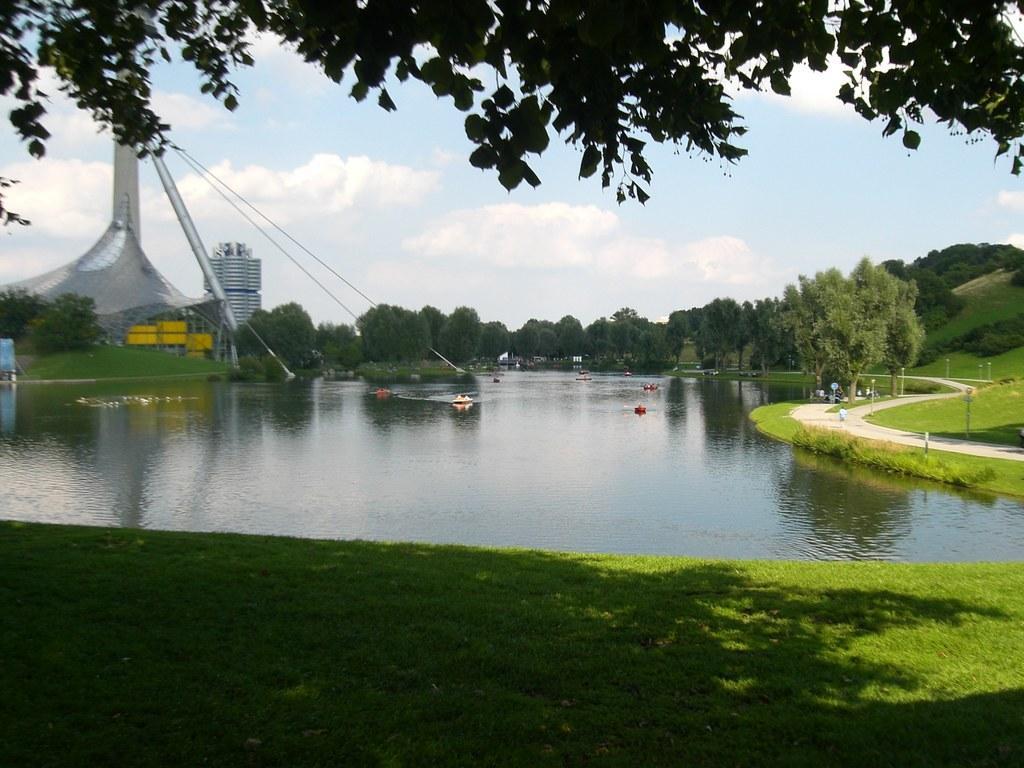In one or two sentences, can you explain what this image depicts? In this picture I can see there is a lake, there is a walkway and there is grass. There are few trees and there are two buildings at left side and the sky is clear. 